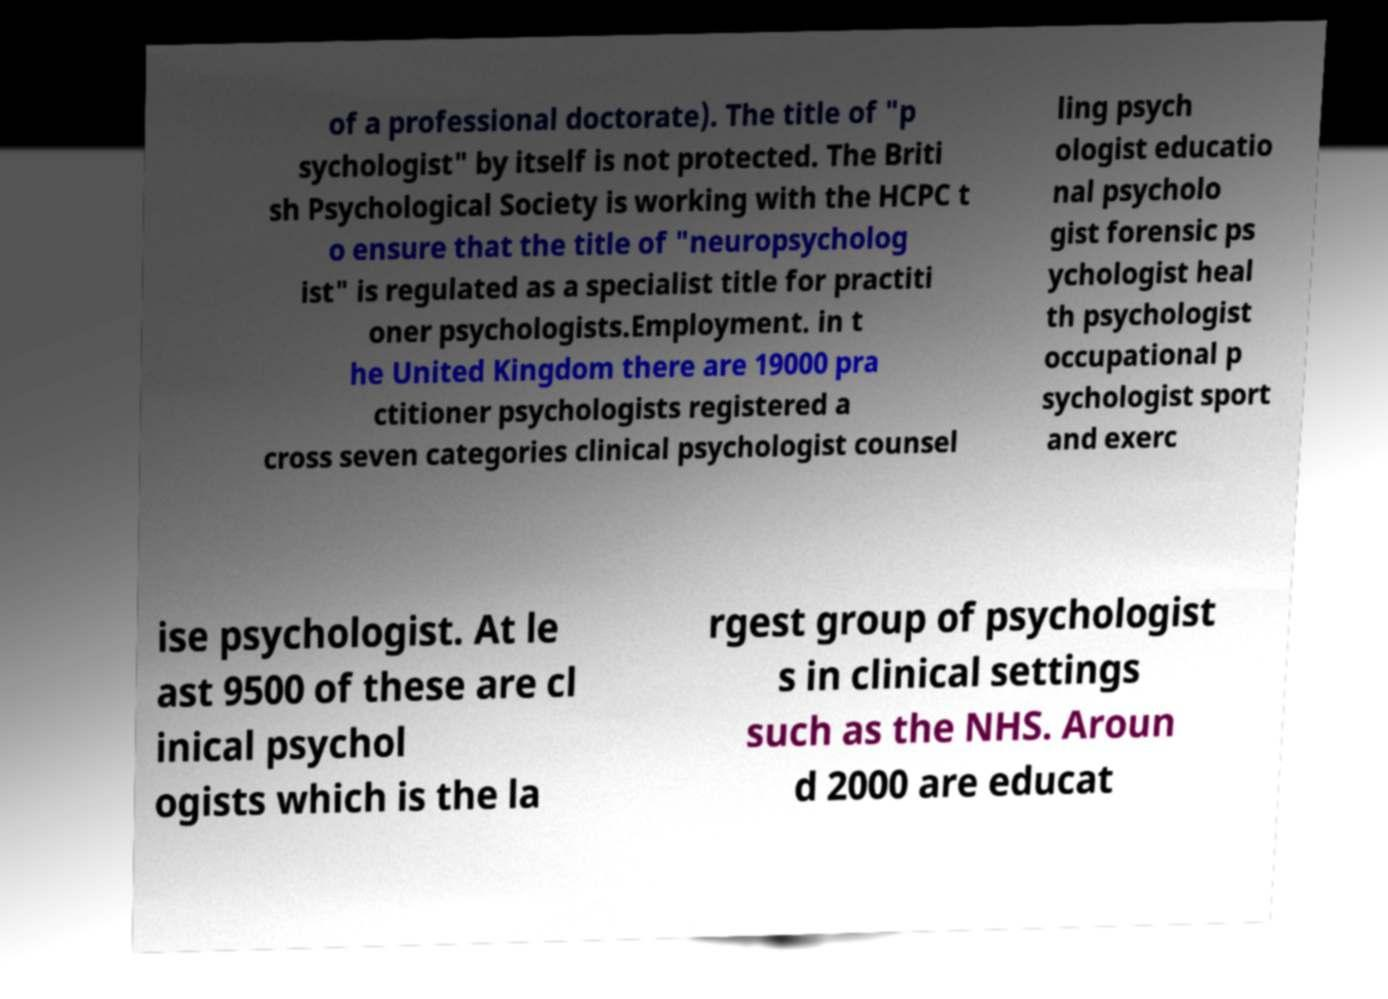Please read and relay the text visible in this image. What does it say? of a professional doctorate). The title of "p sychologist" by itself is not protected. The Briti sh Psychological Society is working with the HCPC t o ensure that the title of "neuropsycholog ist" is regulated as a specialist title for practiti oner psychologists.Employment. in t he United Kingdom there are 19000 pra ctitioner psychologists registered a cross seven categories clinical psychologist counsel ling psych ologist educatio nal psycholo gist forensic ps ychologist heal th psychologist occupational p sychologist sport and exerc ise psychologist. At le ast 9500 of these are cl inical psychol ogists which is the la rgest group of psychologist s in clinical settings such as the NHS. Aroun d 2000 are educat 